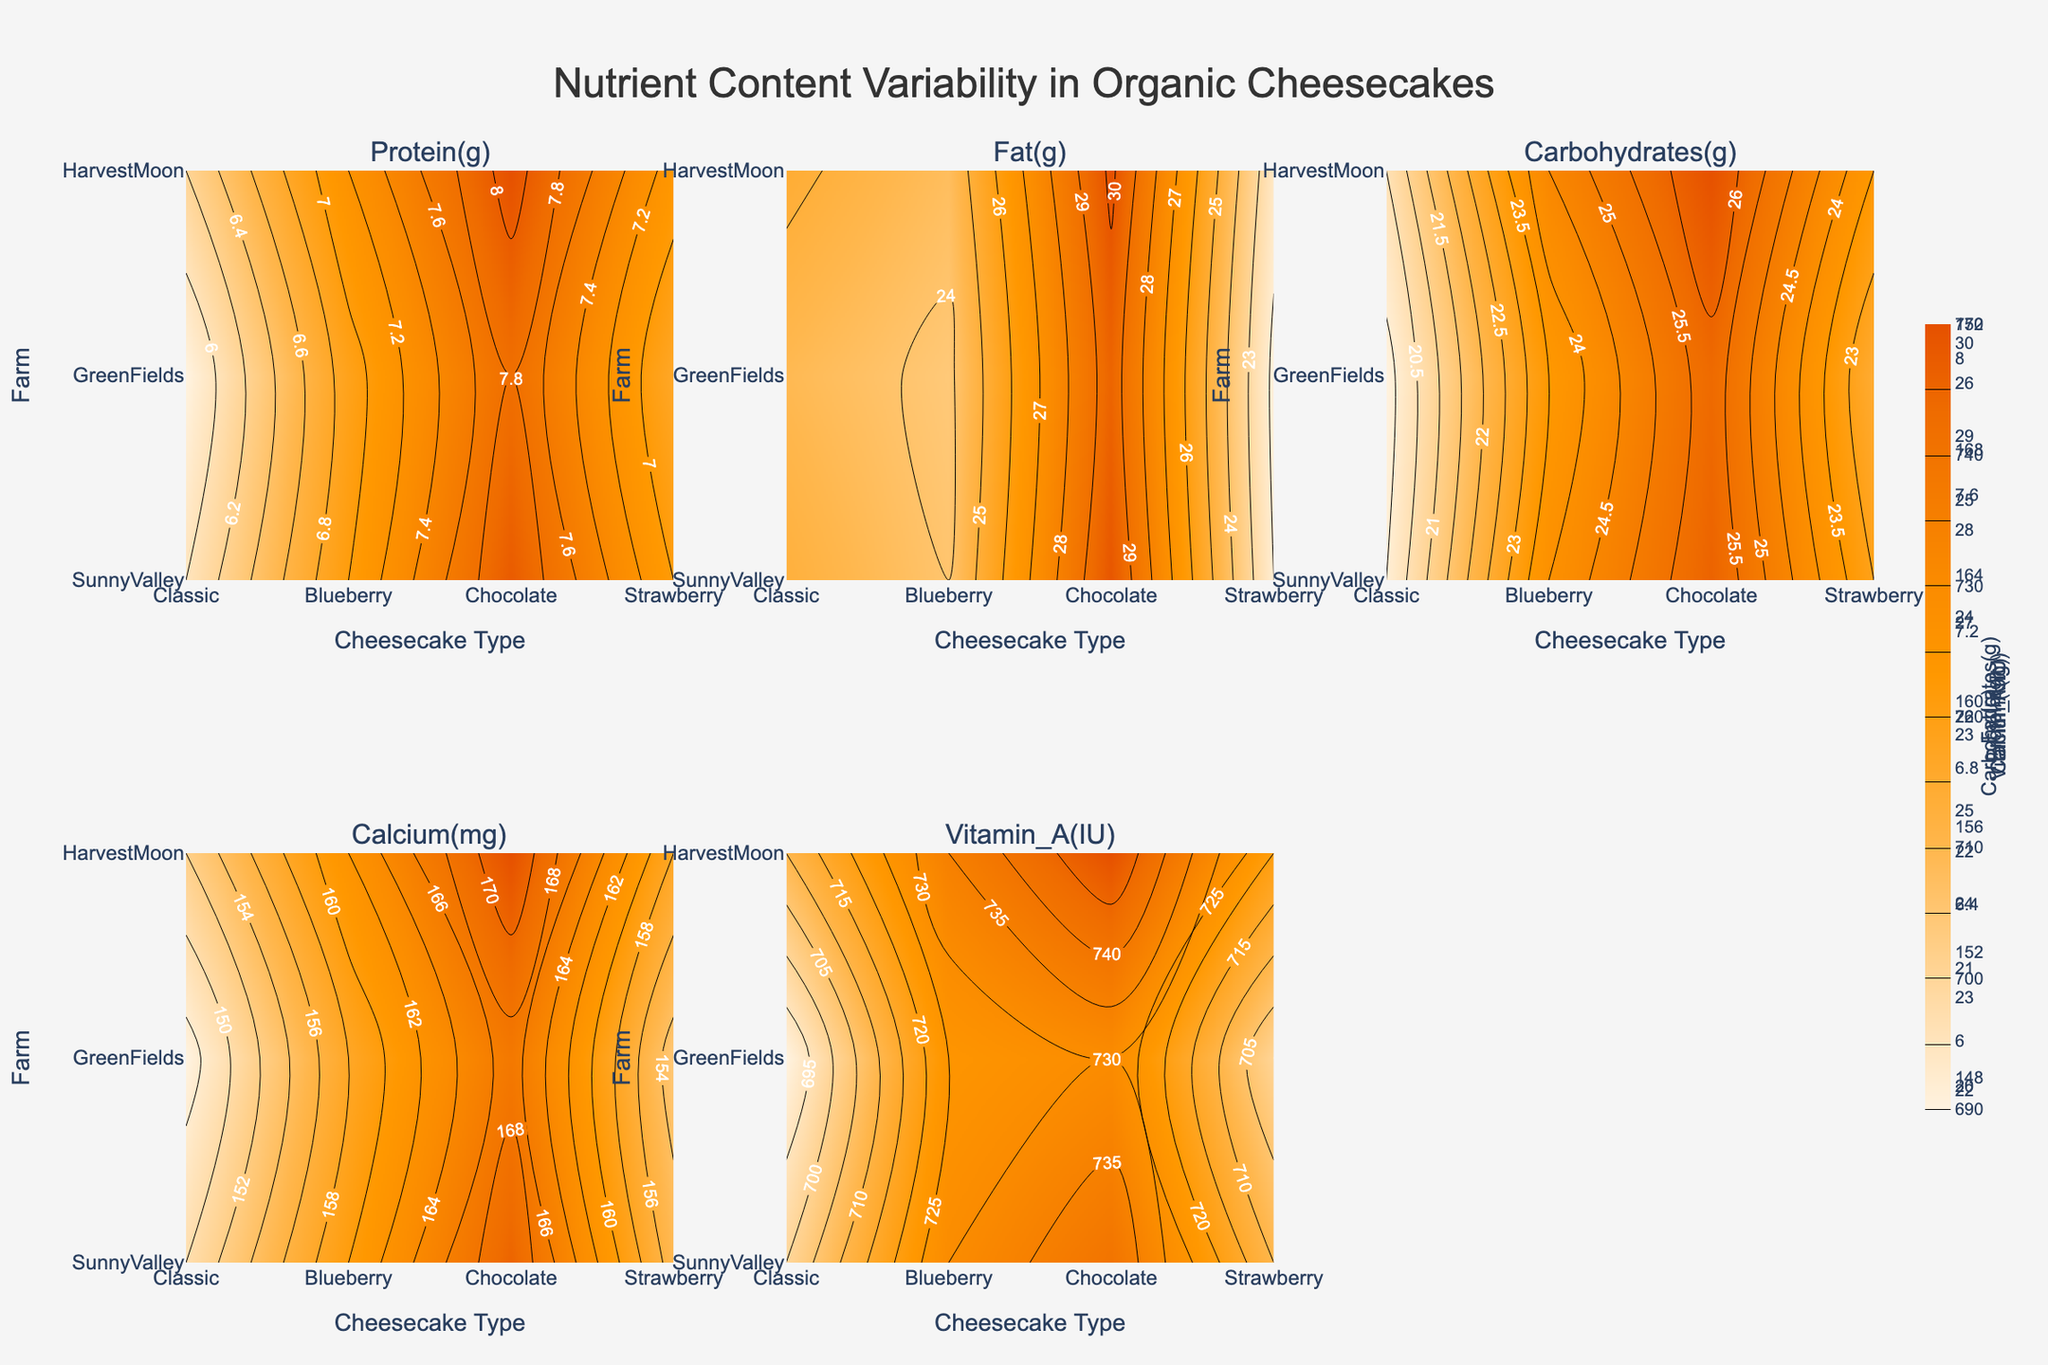What is the title of the figure? The title of the figure is usually displayed at the top. In this case, it says "Nutrient Content Variability in Organic Cheesecakes".
Answer: Nutrient Content Variability in Organic Cheesecakes Which nutrient subplot shows the highest variability between farms for the Chocolate cheesecake? To determine the highest variability, look at the range of contour lines within the Chocolate cheesecake column across different farm rows for each nutrient subplot. More densely packed or widely ranged contours indicate higher variability.
Answer: Fat(g) How many nutrients are being measured in this figure? The subplot titles represent the nutrients being measured. Count these titles to determine the total number.
Answer: 5 Which farm has the highest protein content for the Classic cheesecake? Locate the protein subplot and find the Classic cheesecake type along the x-axis. Then, identify the highest contour value along the y-axis for farms.
Answer: HarvestMoon What is the average fat content in Blueberry cheesecakes across all farms? Look at the fat subplot, focus on the Blueberry cheesecake column, and find the fat content value for each farm on the y-axis. Calculate the average of these values: (24 + 23.8 + 24.3) / 3.
Answer: 24.03 Which farm has the lowest Vitamin A content for the Strawberry cheesecake? Locate the Vitamin A subplot, identify the Strawberry cheesecake type along the x-axis, and look for the minimum contour value along the y-axis for the farms.
Answer: GreenFields Between SunnyValley and GreenFields, which one produces cheesecakes with higher average calcium content? Calculate the average calcium content across all cheesecake types (Classic, Blueberry, Chocolate, Strawberry) for both farms. Then, compare the two averages.
Answer: SunnyValley For the Cheesecake_Type Classic, which nutrient shows the smallest variability across different farms? Look at all subplots corresponding to the Classic cheesecake column. Identify the one with the most consistent contour values across the farm rows.
Answer: Calcium(mg) Comparing GreenFields across all cheesecake types, which nutrient measures are most variable? Check the contours for GreenFields across different cheesecake types for all subplots. The one with the most variation in contour density and range is the most variable.
Answer: Fat(g) How does the carbohydrate content in SunnyValley cheesecakes compare between Blueberry and Strawberry types? Locate the Carbohydrates(g) subplot, identify the contours for SunnyValley in the rows of Blueberry and Strawberry cheesecake columns and compare them.
Answer: Strawberry has less than Blueberry 